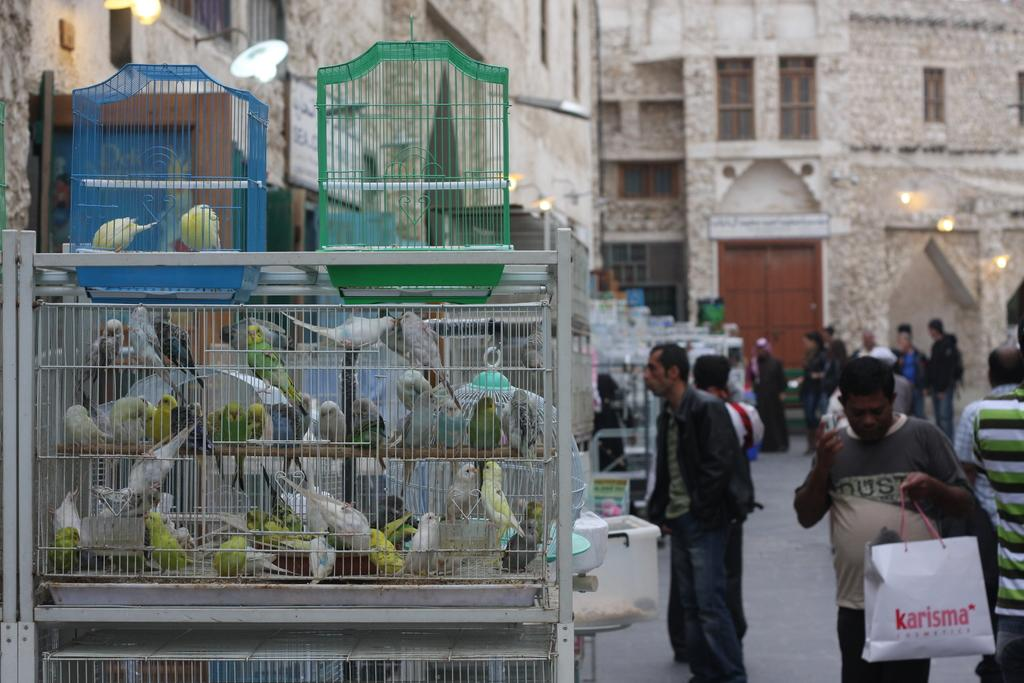What type of animals are in cages in the image? There are birds in cages in the image. What can be seen on the ground in the image? There is a group of people on the ground in the image. What is illuminating the scene in the image? There are lights visible in the image. What else is present in the image besides the birds and people? There are objects present in the image. What type of structures can be seen in the background of the image? There are buildings with windows in the background of the image. What type of quartz can be seen in the image? There is no quartz present in the image. Can you see any squirrels interacting with the birds in the cages? There are no squirrels present in the image; only birds in cages and a group of people on the ground can be seen. 